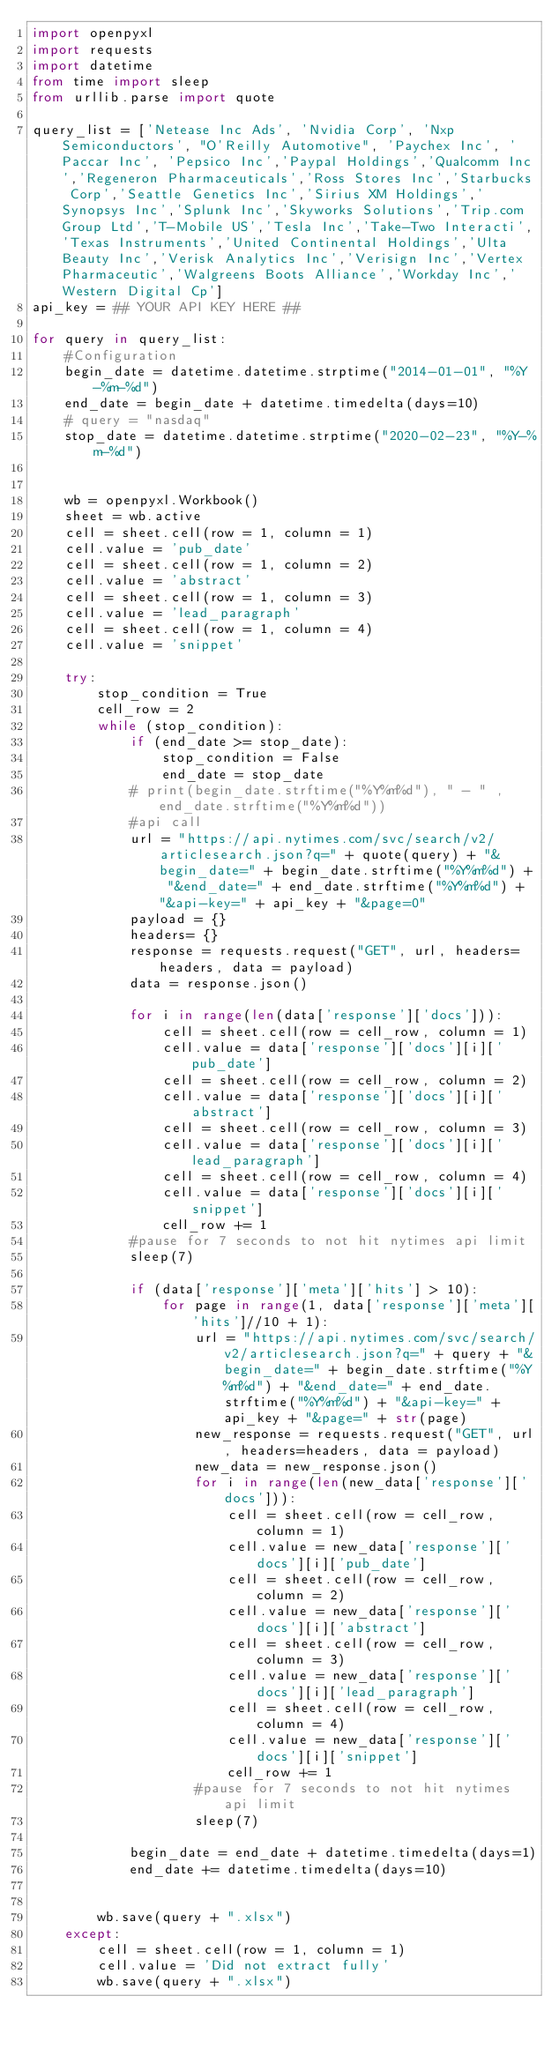<code> <loc_0><loc_0><loc_500><loc_500><_Python_>import openpyxl
import requests
import datetime
from time import sleep
from urllib.parse import quote

query_list = ['Netease Inc Ads', 'Nvidia Corp', 'Nxp Semiconductors', "O'Reilly Automotive", 'Paychex Inc', 'Paccar Inc', 'Pepsico Inc','Paypal Holdings','Qualcomm Inc','Regeneron Pharmaceuticals','Ross Stores Inc','Starbucks Corp','Seattle Genetics Inc','Sirius XM Holdings','Synopsys Inc','Splunk Inc','Skyworks Solutions','Trip.com Group Ltd','T-Mobile US','Tesla Inc','Take-Two Interacti','Texas Instruments','United Continental Holdings','Ulta Beauty Inc','Verisk Analytics Inc','Verisign Inc','Vertex Pharmaceutic','Walgreens Boots Alliance','Workday Inc','Western Digital Cp']
api_key = ## YOUR API KEY HERE ##

for query in query_list:
    #Configuration
    begin_date = datetime.datetime.strptime("2014-01-01", "%Y-%m-%d")
    end_date = begin_date + datetime.timedelta(days=10)
    # query = "nasdaq"
    stop_date = datetime.datetime.strptime("2020-02-23", "%Y-%m-%d")


    wb = openpyxl.Workbook()
    sheet = wb.active
    cell = sheet.cell(row = 1, column = 1)
    cell.value = 'pub_date'
    cell = sheet.cell(row = 1, column = 2)
    cell.value = 'abstract'
    cell = sheet.cell(row = 1, column = 3)
    cell.value = 'lead_paragraph'
    cell = sheet.cell(row = 1, column = 4)
    cell.value = 'snippet'

    try:
        stop_condition = True
        cell_row = 2
        while (stop_condition):
            if (end_date >= stop_date):
                stop_condition = False
                end_date = stop_date
            # print(begin_date.strftime("%Y%m%d"), " - " , end_date.strftime("%Y%m%d"))
            #api call
            url = "https://api.nytimes.com/svc/search/v2/articlesearch.json?q=" + quote(query) + "&begin_date=" + begin_date.strftime("%Y%m%d") + "&end_date=" + end_date.strftime("%Y%m%d") + "&api-key=" + api_key + "&page=0"
            payload = {}
            headers= {}
            response = requests.request("GET", url, headers=headers, data = payload)
            data = response.json()

            for i in range(len(data['response']['docs'])):
                cell = sheet.cell(row = cell_row, column = 1)
                cell.value = data['response']['docs'][i]['pub_date']
                cell = sheet.cell(row = cell_row, column = 2)
                cell.value = data['response']['docs'][i]['abstract']
                cell = sheet.cell(row = cell_row, column = 3)
                cell.value = data['response']['docs'][i]['lead_paragraph']
                cell = sheet.cell(row = cell_row, column = 4)
                cell.value = data['response']['docs'][i]['snippet']
                cell_row += 1
            #pause for 7 seconds to not hit nytimes api limit
            sleep(7)

            if (data['response']['meta']['hits'] > 10):
                for page in range(1, data['response']['meta']['hits']//10 + 1):
                    url = "https://api.nytimes.com/svc/search/v2/articlesearch.json?q=" + query + "&begin_date=" + begin_date.strftime("%Y%m%d") + "&end_date=" + end_date.strftime("%Y%m%d") + "&api-key=" + api_key + "&page=" + str(page)
                    new_response = requests.request("GET", url, headers=headers, data = payload)
                    new_data = new_response.json()
                    for i in range(len(new_data['response']['docs'])):
                        cell = sheet.cell(row = cell_row, column = 1)
                        cell.value = new_data['response']['docs'][i]['pub_date']
                        cell = sheet.cell(row = cell_row, column = 2)
                        cell.value = new_data['response']['docs'][i]['abstract']
                        cell = sheet.cell(row = cell_row, column = 3)
                        cell.value = new_data['response']['docs'][i]['lead_paragraph']
                        cell = sheet.cell(row = cell_row, column = 4)
                        cell.value = new_data['response']['docs'][i]['snippet']
                        cell_row += 1
                    #pause for 7 seconds to not hit nytimes api limit
                    sleep(7)

            begin_date = end_date + datetime.timedelta(days=1)
            end_date += datetime.timedelta(days=10)
            

        wb.save(query + ".xlsx")
    except:
        cell = sheet.cell(row = 1, column = 1)
        cell.value = 'Did not extract fully'
        wb.save(query + ".xlsx")

</code> 